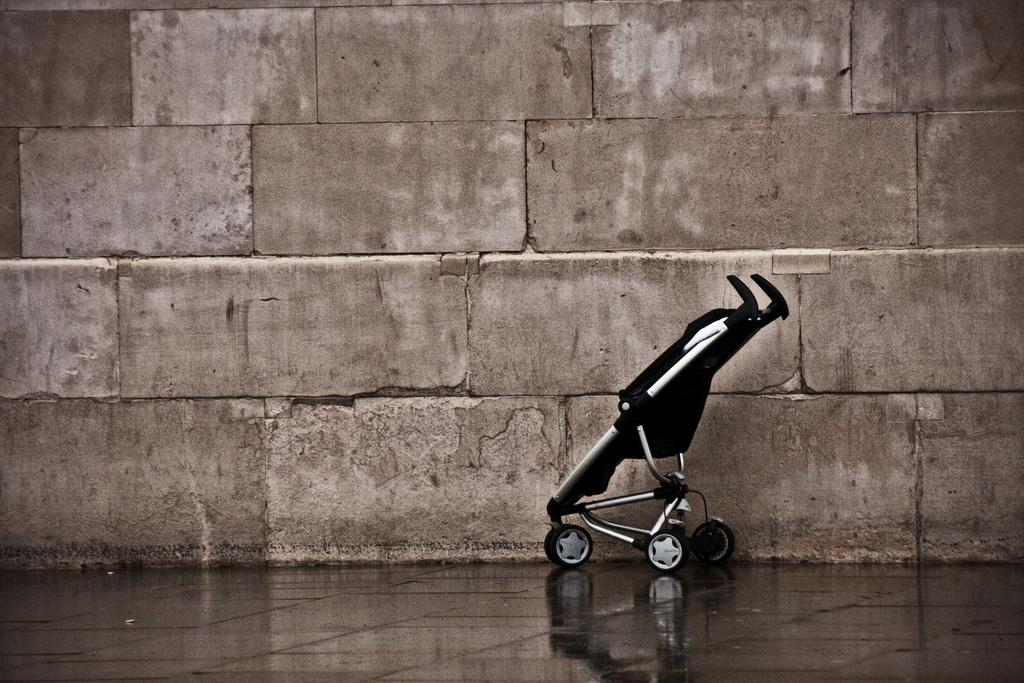What object is located on the floor in the image? There is a baby carriage on the floor in the image. What can be seen in the background of the image? There is a wall in the background of the image. What type of bird is sitting on the baby carriage in the image? There is no bird present in the image; it only features a baby carriage on the floor and a wall in the background. 